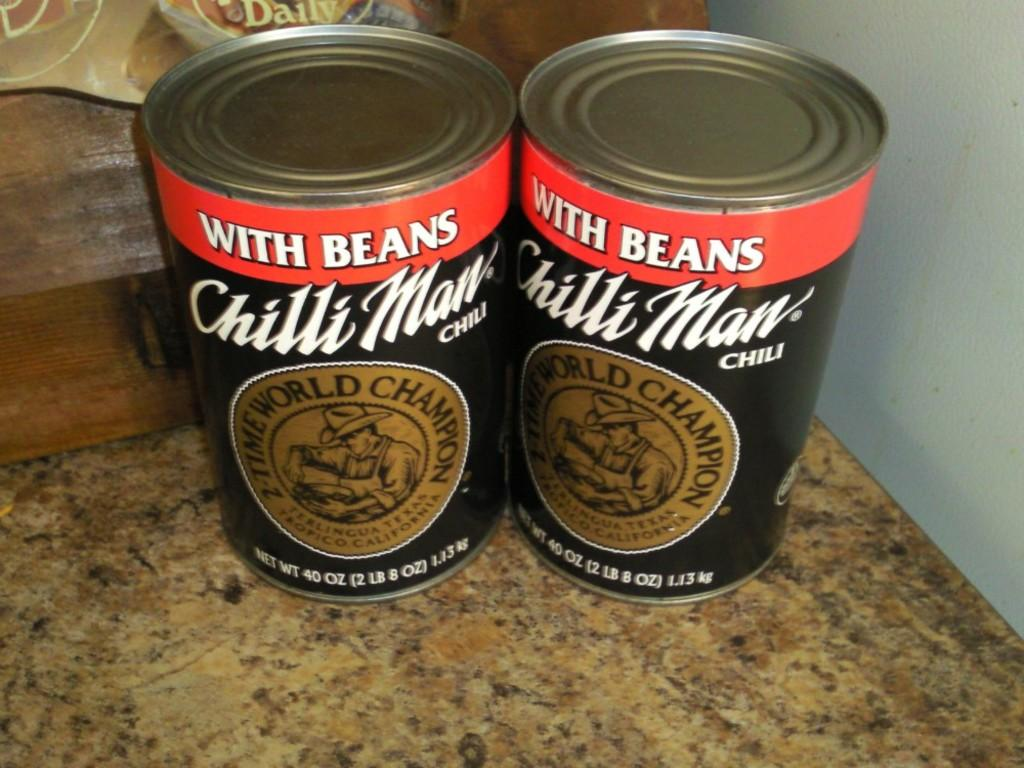<image>
Provide a brief description of the given image. Two cans of chili with beans are side by side on a counter. 